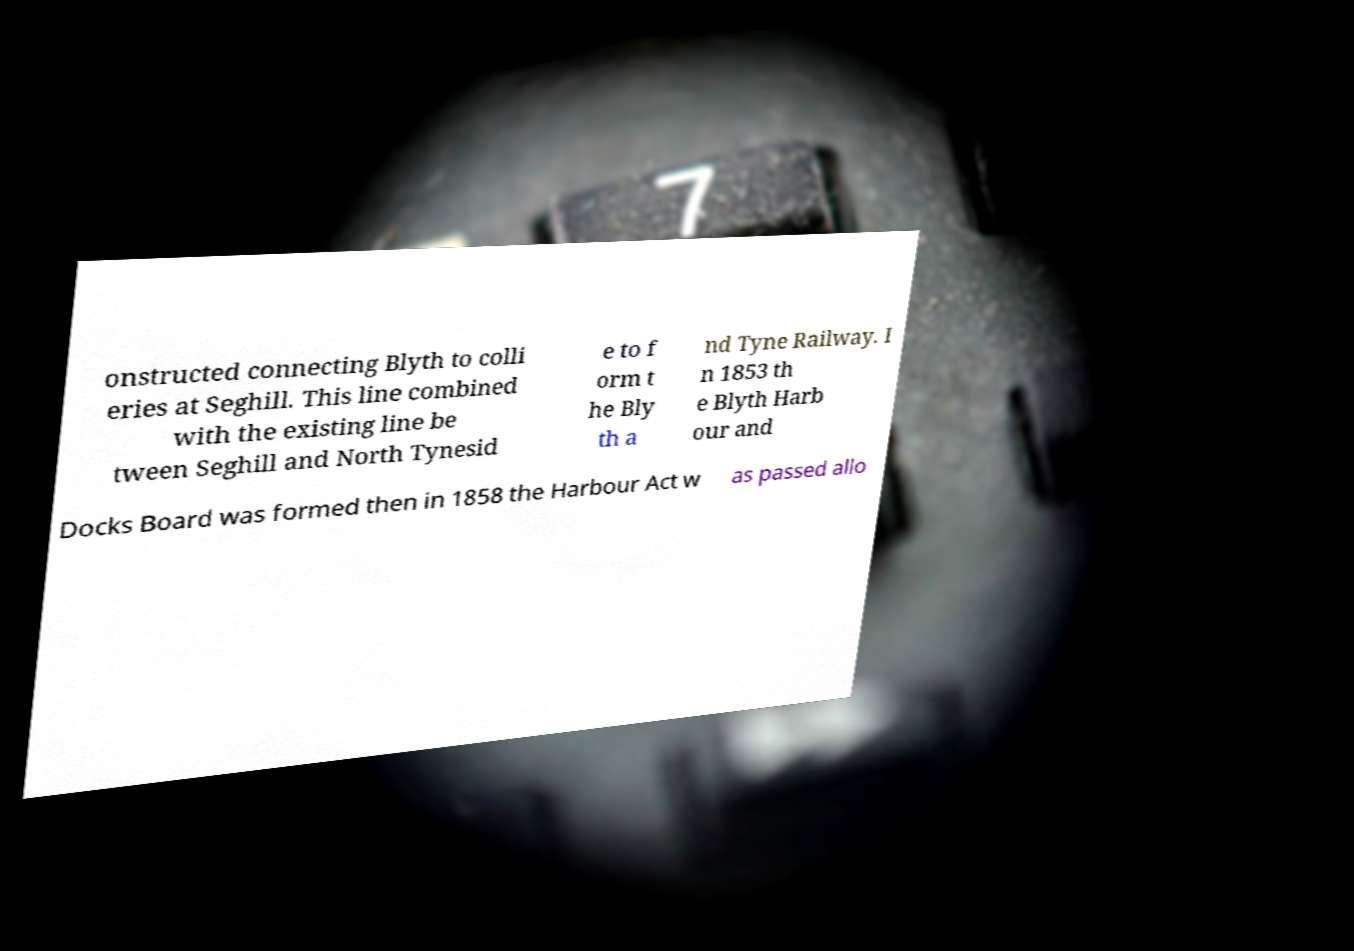Can you accurately transcribe the text from the provided image for me? onstructed connecting Blyth to colli eries at Seghill. This line combined with the existing line be tween Seghill and North Tynesid e to f orm t he Bly th a nd Tyne Railway. I n 1853 th e Blyth Harb our and Docks Board was formed then in 1858 the Harbour Act w as passed allo 